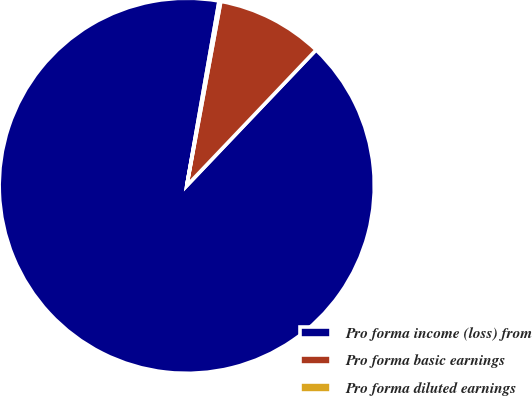Convert chart. <chart><loc_0><loc_0><loc_500><loc_500><pie_chart><fcel>Pro forma income (loss) from<fcel>Pro forma basic earnings<fcel>Pro forma diluted earnings<nl><fcel>90.64%<fcel>9.2%<fcel>0.15%<nl></chart> 